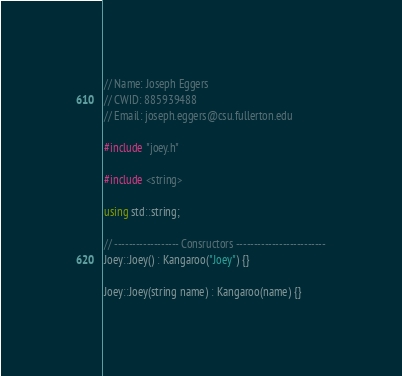<code> <loc_0><loc_0><loc_500><loc_500><_C++_>// Name: Joseph Eggers
// CWID: 885939488
// Email: joseph.eggers@csu.fullerton.edu

#include "joey.h"

#include <string>

using std::string;

// ------------------ Consructors -------------------------
Joey::Joey() : Kangaroo("Joey") {}

Joey::Joey(string name) : Kangaroo(name) {}
</code> 